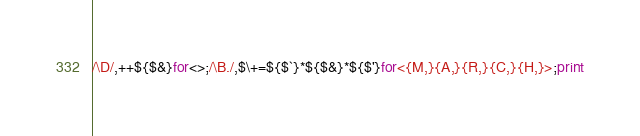<code> <loc_0><loc_0><loc_500><loc_500><_Perl_>/\D/,++${$&}for<>;/\B./,$\+=${$`}*${$&}*${$'}for<{M,}{A,}{R,}{C,}{H,}>;print</code> 